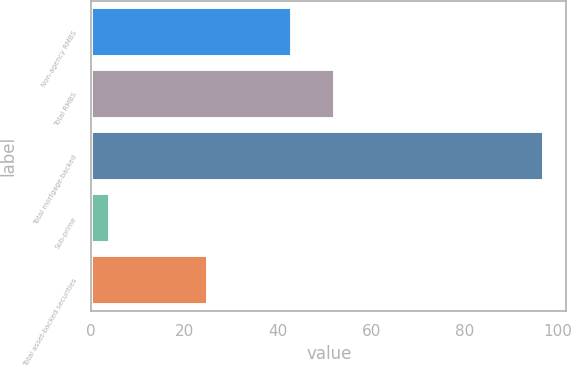Convert chart to OTSL. <chart><loc_0><loc_0><loc_500><loc_500><bar_chart><fcel>Non-agency RMBS<fcel>Total RMBS<fcel>Total mortgage-backed<fcel>Sub-prime<fcel>Total asset-backed securities<nl><fcel>43<fcel>52.3<fcel>97<fcel>4<fcel>25<nl></chart> 